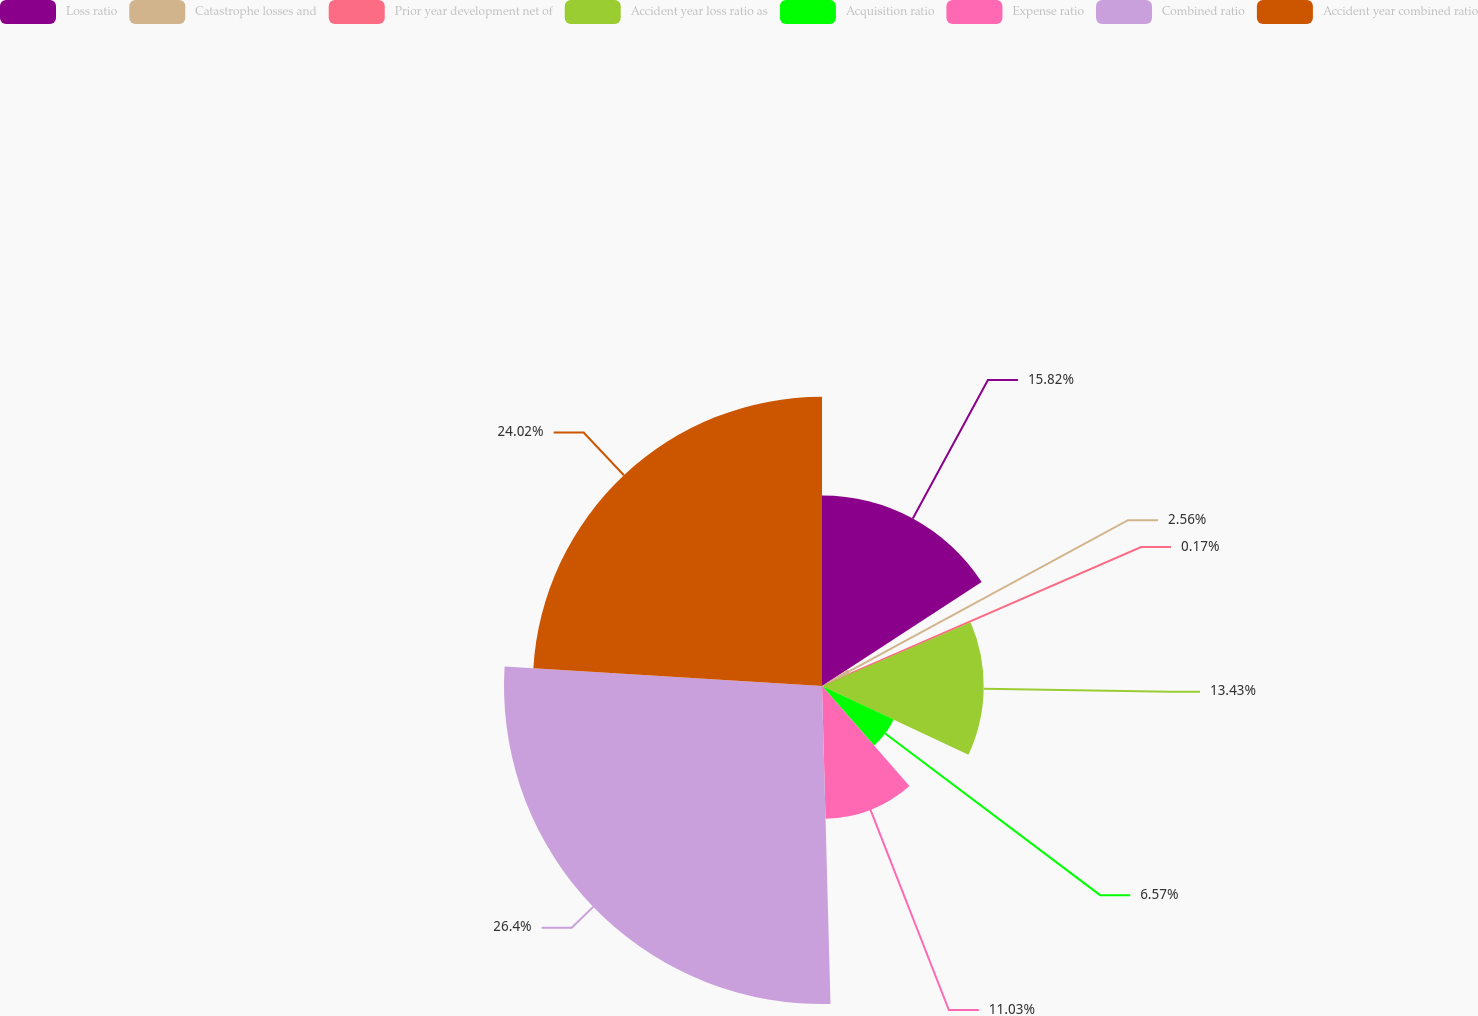Convert chart to OTSL. <chart><loc_0><loc_0><loc_500><loc_500><pie_chart><fcel>Loss ratio<fcel>Catastrophe losses and<fcel>Prior year development net of<fcel>Accident year loss ratio as<fcel>Acquisition ratio<fcel>Expense ratio<fcel>Combined ratio<fcel>Accident year combined ratio<nl><fcel>15.82%<fcel>2.56%<fcel>0.17%<fcel>13.43%<fcel>6.57%<fcel>11.03%<fcel>26.41%<fcel>24.02%<nl></chart> 